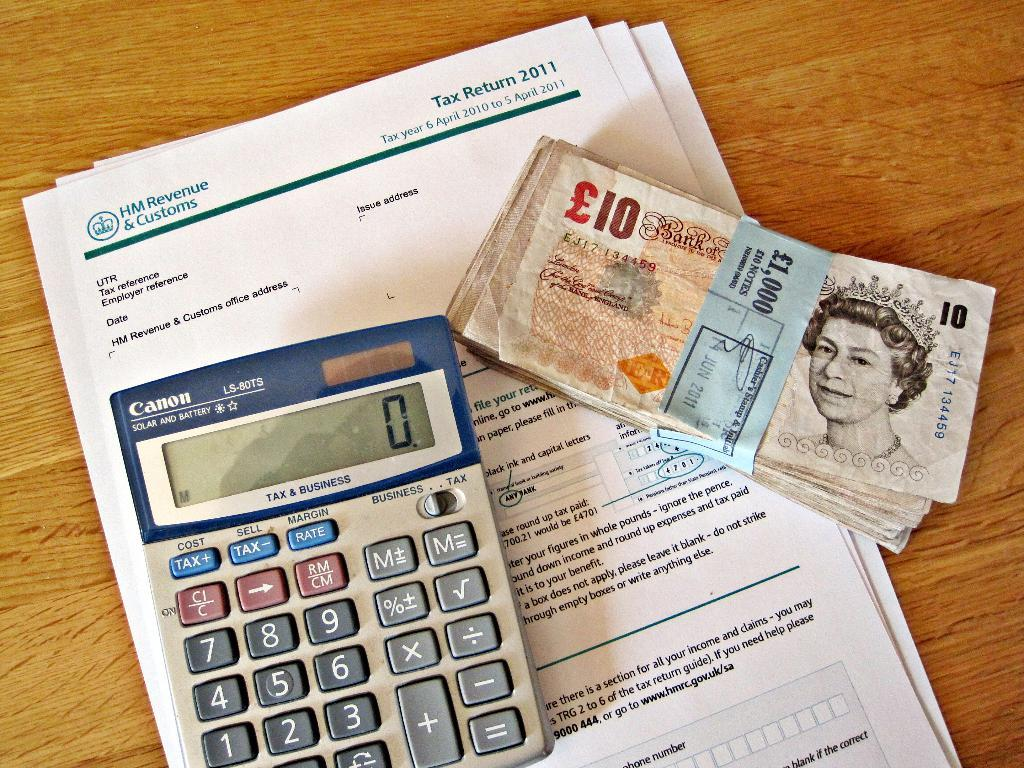<image>
Write a terse but informative summary of the picture. a calculator next to 10 bills and on papers reading HM Revenue & Customs 